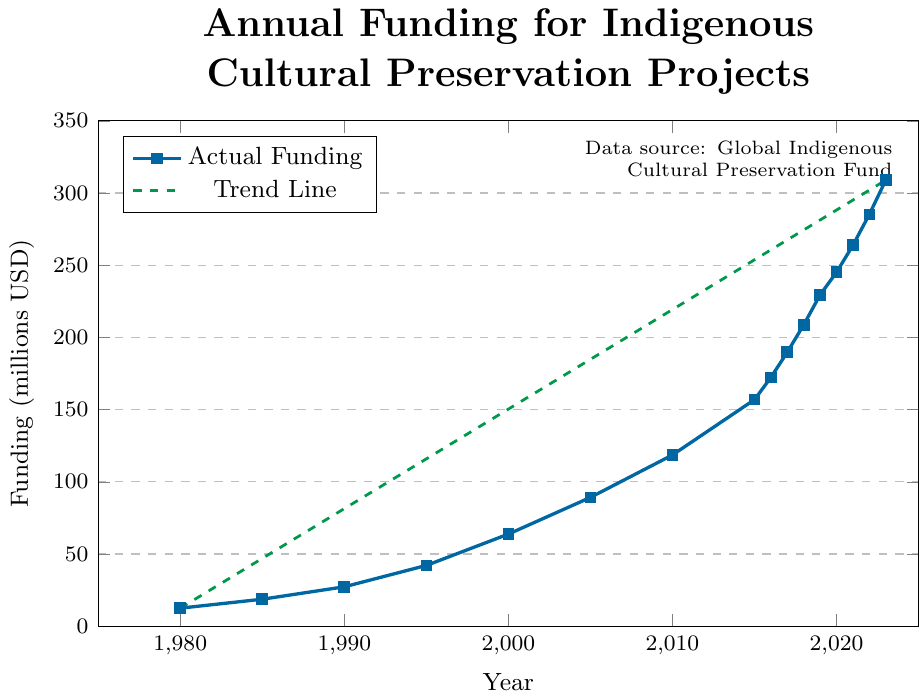How much did the funding increase between 1990 and 1995? The funding in 1990 was 27.3 million USD, and in 1995 it was 42.1 million USD. The increase is calculated by subtracting the 1990 funding from the 1995 funding: 42.1 - 27.3.
Answer: 14.8 million USD Which year saw the highest funding allocation in the dataset? The highest funding allocation was in 2023 with 308.9 million USD.
Answer: 2023 By how much did the funding grow between 2010 and 2023? The funding in 2010 was 118.6 million USD, and in 2023 it was 308.9 million USD. The growth is calculated as 308.9 - 118.6.
Answer: 190.3 million USD Was there any year in the dataset where funding dropped compared to the previous year? By examining the figure, all the years show a steady increase in funding with no drops compared to the previous year.
Answer: No What is the average funding allocation from 1980 to 2023? Sum all the funding values from 1980 to 2023 and then divide by the number of years: (12.5 + 18.7 + 27.3 + 42.1 + 63.8 + 89.2 + 118.6 + 156.9 + 172.3 + 189.8 + 208.7 + 229.5 + 245.1 + 263.8 + 285.2 + 308.9) / 16 = 2053.5 / 16
Answer: 128.3 million USD How did the funding change from 2017 to 2019? The funding in 2017 was 189.8 million USD, and in 2019 it was 229.5 million USD. The change is calculated as 229.5 - 189.8.
Answer: 39.7 million USD Which period saw the largest incremental increase in funding: 1980-1995 or 2000-2015? 1980-1995 saw an increase from 12.5 million USD to 42.1 million USD, which is 42.1 - 12.5 = 29.6 million USD. The period from 2000-2015 saw an increase from 63.8 million USD to 156.9 million USD, which is 156.9 - 63.8 = 93.1 million USD.
Answer: 2000-2015 What funding trend can be observed between 2000 and 2010? The funding steadily increased from 63.8 million USD in 2000 to 118.6 million USD in 2010.
Answer: Increasing How much more funding was allocated in 2023 compared to 1985? The funding in 2023 was 308.9 million USD, and in 1985 it was 18.7 million USD. The difference is calculated as 308.9 - 18.7.
Answer: 290.2 million USD What is the overall trend of funding allocation from 1980 to 2023? The overall trend shows a consistent increase in funding allocation over the years, as indicated by the upward slope of the trend line.
Answer: Increasing 